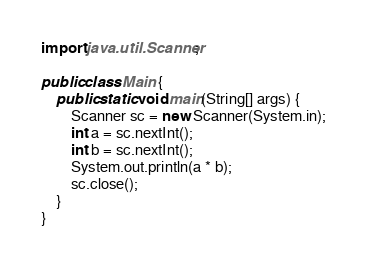Convert code to text. <code><loc_0><loc_0><loc_500><loc_500><_Java_>import java.util.Scanner;

public class Main {
	public static void main(String[] args) {
		Scanner sc = new Scanner(System.in);
		int a = sc.nextInt();
		int b = sc.nextInt();
		System.out.println(a * b);
		sc.close();
	}
}</code> 